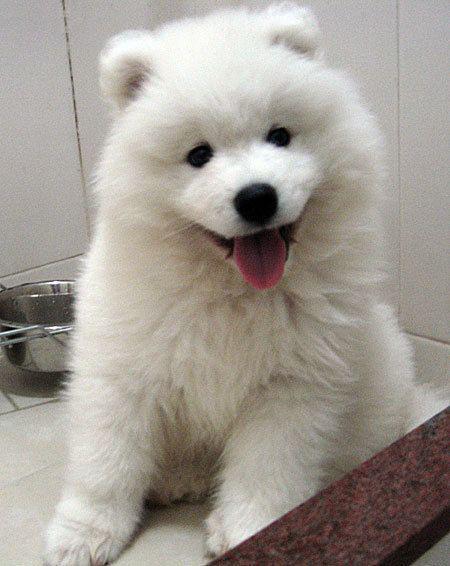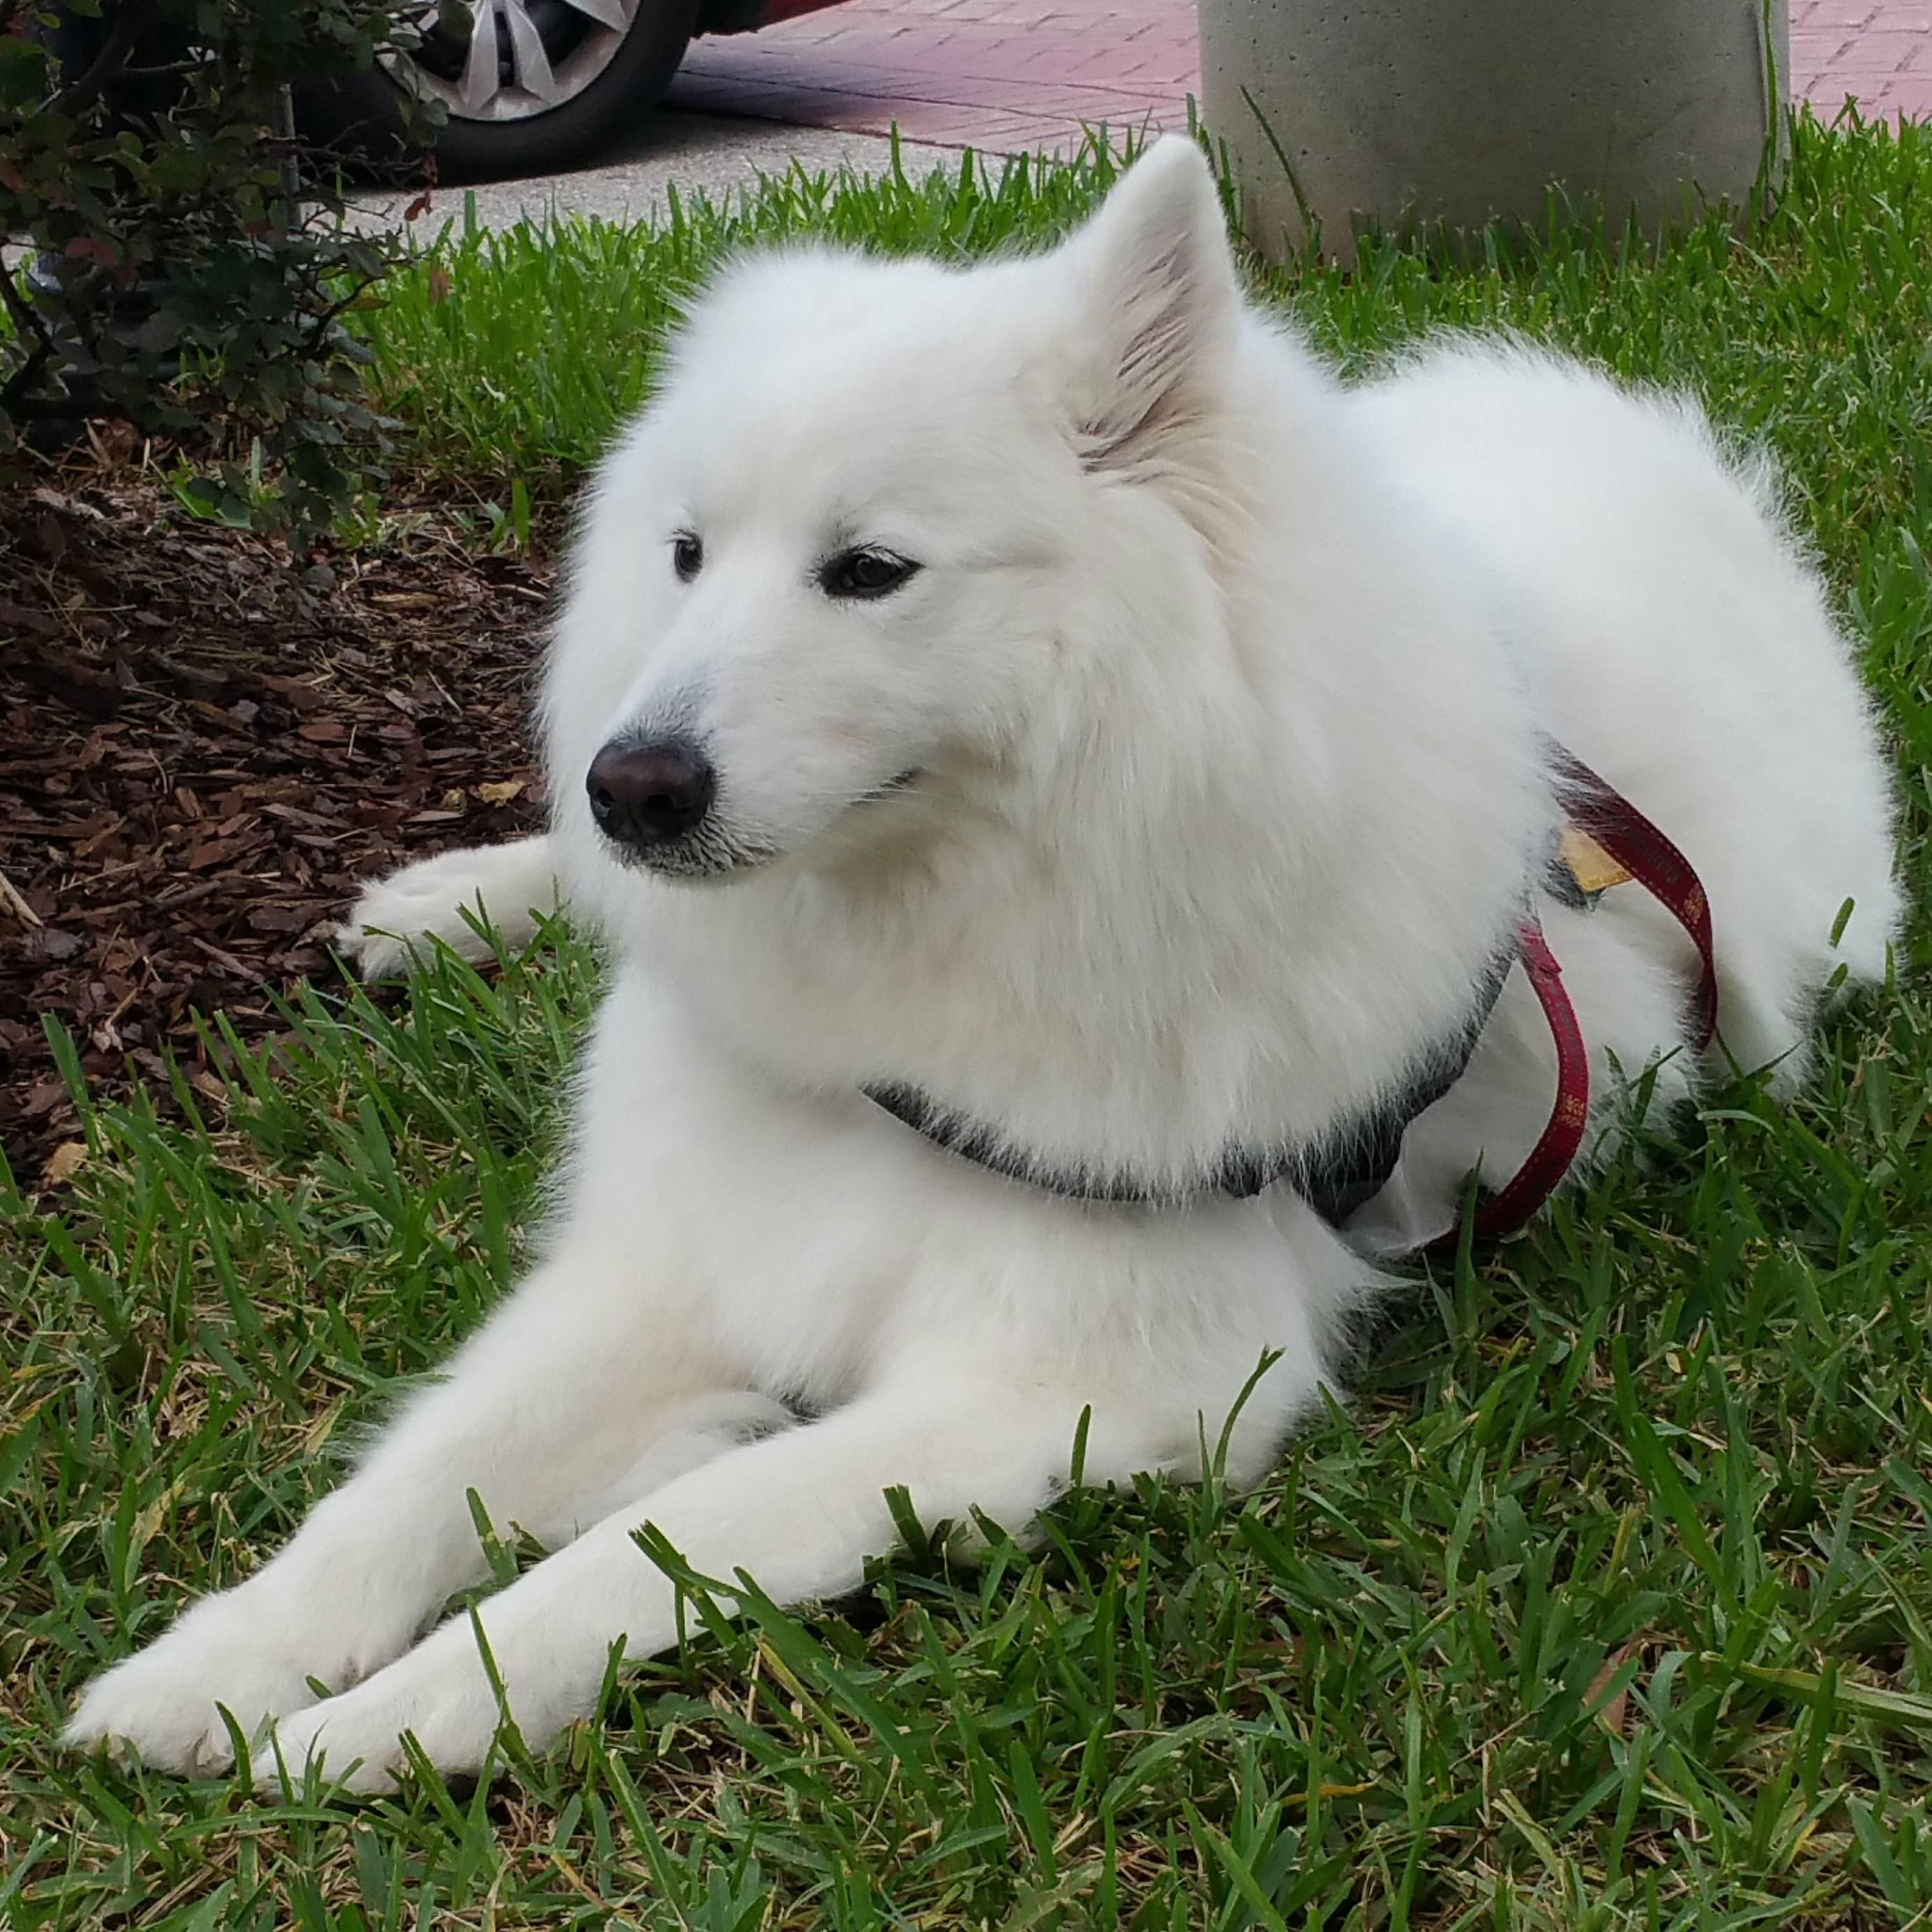The first image is the image on the left, the second image is the image on the right. For the images displayed, is the sentence "there is grass visible behind a white dog." factually correct? Answer yes or no. Yes. The first image is the image on the left, the second image is the image on the right. Considering the images on both sides, is "One image contains multiple white dog figures, and the other image shows one white dog held up by a human arm." valid? Answer yes or no. No. 